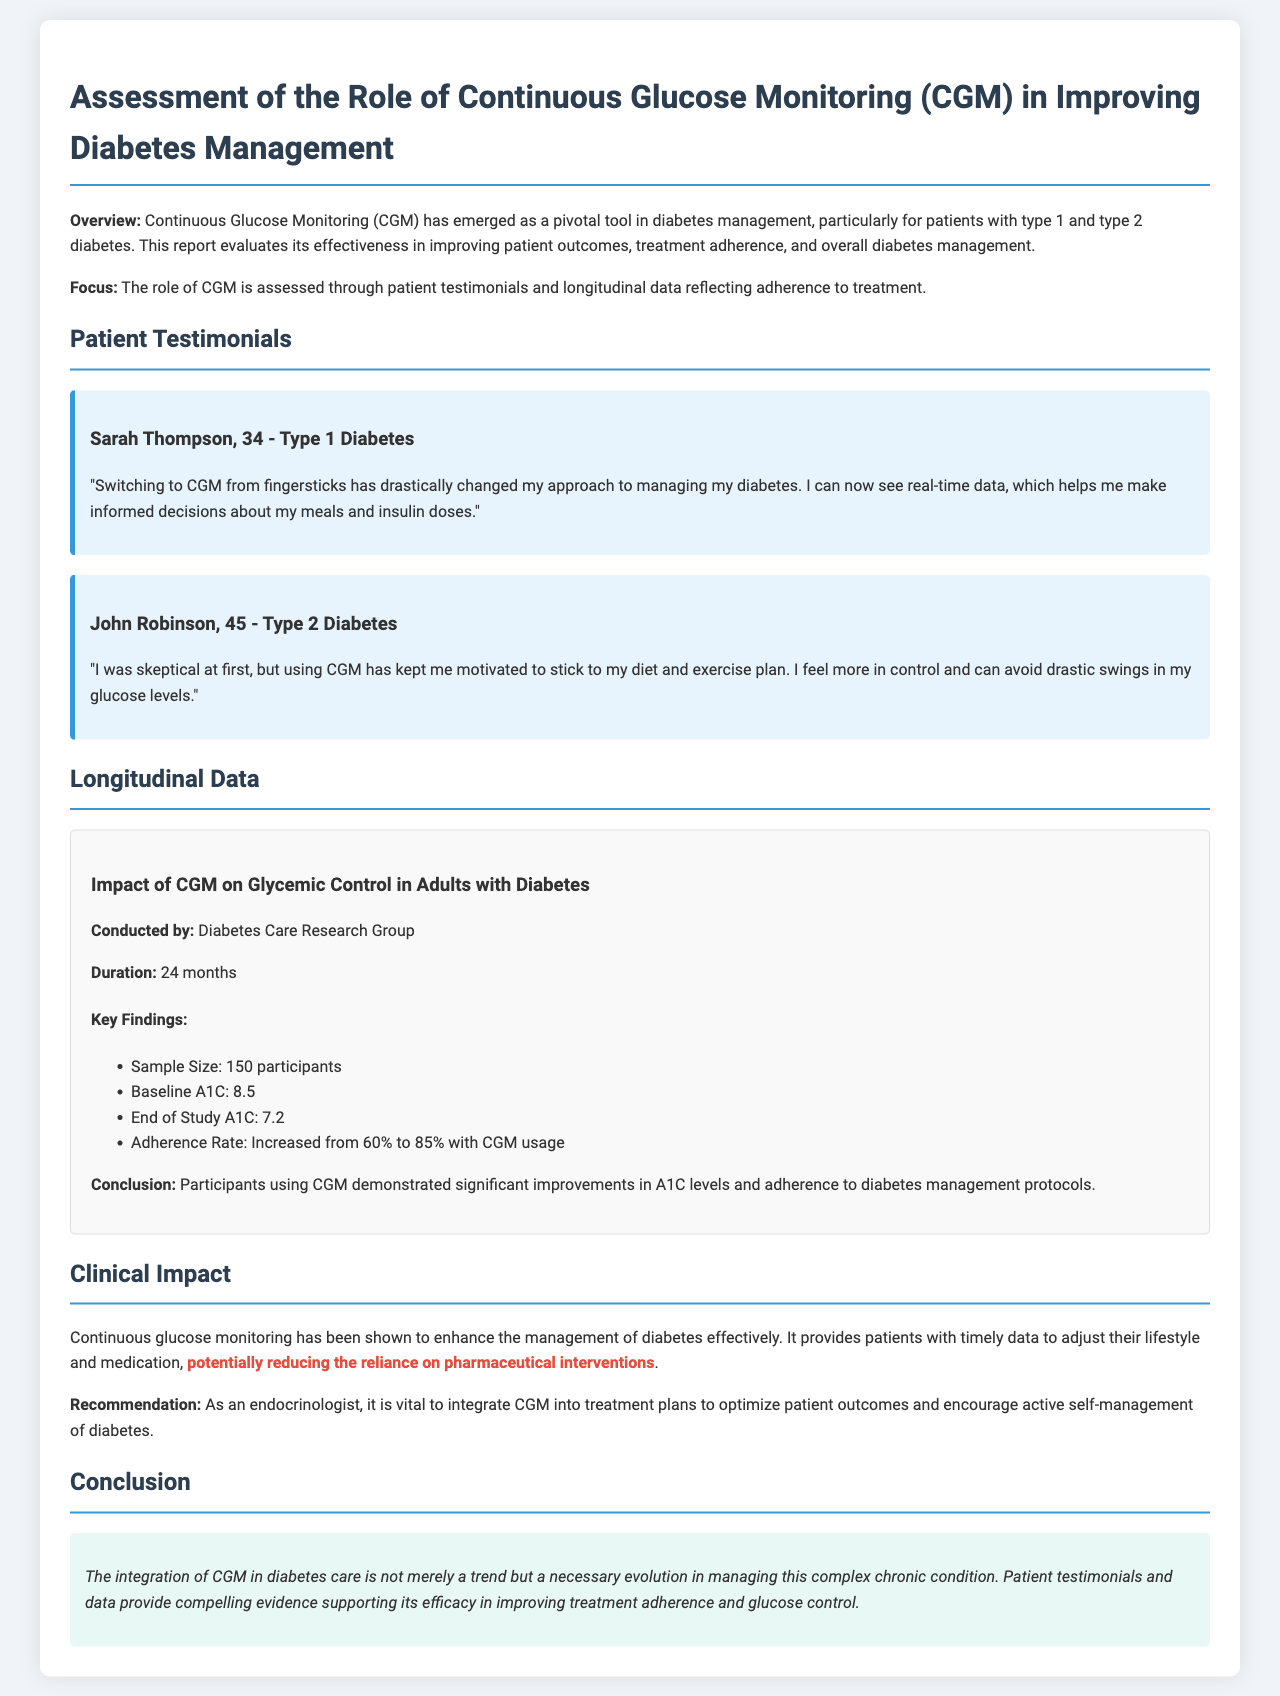what is the duration of the study? The study duration is explicitly mentioned in the document as 24 months.
Answer: 24 months who conducted the study? The document specifies that the Diabetes Care Research Group conducted the study.
Answer: Diabetes Care Research Group what was the sample size of the study? The sample size is stated in the findings section of the document as 150 participants.
Answer: 150 participants what was the baseline A1C level? This detail is provided in the longitudinal data section, indicating a baseline A1C level of 8.5.
Answer: 8.5 what was the end of study A1C level? The document specifies that the end of study A1C level was 7.2.
Answer: 7.2 how much did the adherence rate increase? The increase in adherence rate is highlighted as going from 60% to 85%.
Answer: 60% to 85% what was Sarah Thompson's diabetes type? In the testimonial section, Sarah Thompson is identified as having Type 1 diabetes.
Answer: Type 1 Diabetes what effect does CGM have on pharmaceutical interventions according to the document? The document suggests that CGM has the potential to reduce reliance on pharmaceutical interventions.
Answer: reducing reliance on pharmaceutical interventions what is the main conclusion of the report? The conclusion summarizes that integrating CGM in diabetes care is crucial for improving treatment adherence and glucose control.
Answer: improving treatment adherence and glucose control 